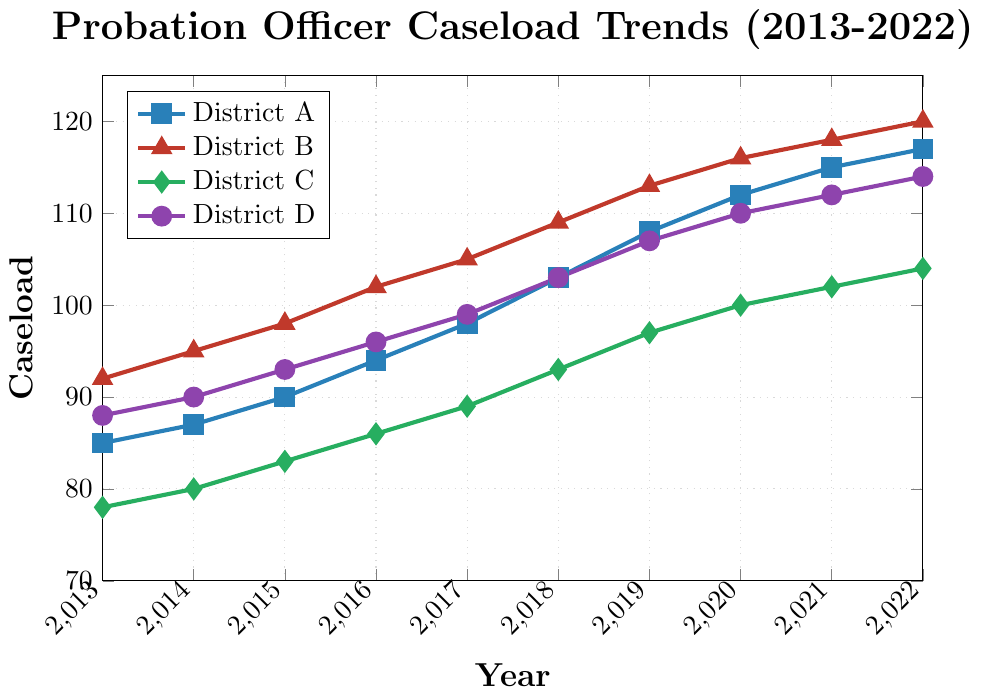What's the caseload trend for District A from 2013 to 2022? To determine the trend, observe the values for District A over the years. The caseload shows a steady increase from 85 in 2013 to 117 in 2022.
Answer: Steady increase Which district had the highest caseload in 2015? Compare the caseloads of all districts in 2015. District B had the highest caseload with 98 cases.
Answer: District B How does the caseload in District C in 2013 compare to its caseload in 2022? The caseload for District C in 2013 was 78, and in 2022 it was 104. By comparing these values, we see an increase of 26 cases.
Answer: Increased by 26 What was the average caseload of District D from 2015 to 2020? Find the caseloads from 2015 to 2020: 93, 96, 99, 103, 107, and 110. Calculate the average: (93+96+99+103+107+110)/6 = 101.33.
Answer: 101.33 Between District A and District B, which one had a higher caseload in 2020? The caseload for District A in 2020 was 112, while for District B it was 116. District B had a higher caseload.
Answer: District B What is the rate of increase in caseload for District A from 2013 to 2022? Determine the difference in caseload from 2013 (85 cases) to 2022 (117 cases), which is 32 cases. Then divide by the number of years (9) to find the average annual increase: 32/9 ≈ 3.56 cases/year.
Answer: 3.56 cases/year Which district had the smallest increase in caseload from 2013 to 2022? Calculate the increase for each district from 2013 to 2022: District A (117-85=32), District B (120-92=28), District C (104-78=26), District D (114-88=26). Districts C and D had the smallest increase, both with 26 cases.
Answer: Districts C and D How does District D's caseload in 2019 compare with the average caseload of District A from 2018 to 2020? First, find the average for District A from 2018 to 2020: (103+108+112)/3 = 107.67. District D's caseload in 2019 is 107. A comparison shows it's slightly lower than the average of District A (107 < 107.67).
Answer: Slightly lower In which year did District B have the largest increase in caseload compared to the previous year? Compare year-on-year differences for District B: 2014-2013 (95-92=3), 2015-2014 (98-95=3), 2016-2015 (102-98=4), 2017-2016 (105-102=3), 2018-2017 (109-105=4), 2019-2018 (113-109=4), 2020-2019 (116-113=3), 2021-2020 (118-116=2), 2022-2021 (120-118=2). The largest increase happened in 2016, 2018, and 2019 with an increase of 4 each.
Answer: 2016, 2018, 2019 What overall trend can be observed for District C from 2013 to 2022? Observe the values for District C. Starting at 78 in 2013 and ending at 104 in 2022, the data shows a consistent increase over the years.
Answer: Consistent increase 